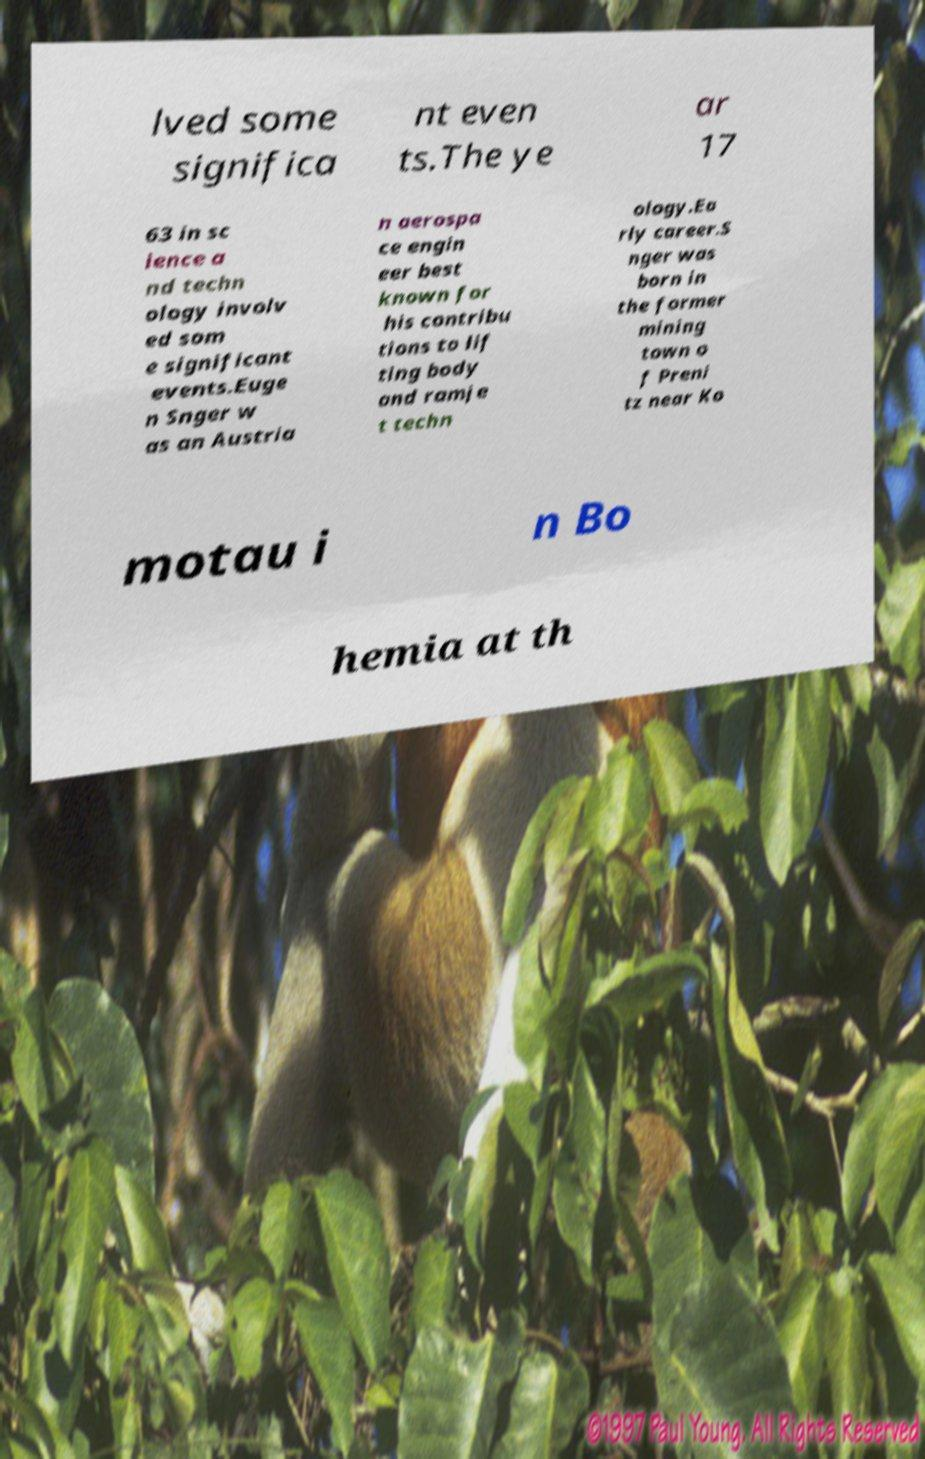Can you accurately transcribe the text from the provided image for me? lved some significa nt even ts.The ye ar 17 63 in sc ience a nd techn ology involv ed som e significant events.Euge n Snger w as an Austria n aerospa ce engin eer best known for his contribu tions to lif ting body and ramje t techn ology.Ea rly career.S nger was born in the former mining town o f Preni tz near Ko motau i n Bo hemia at th 